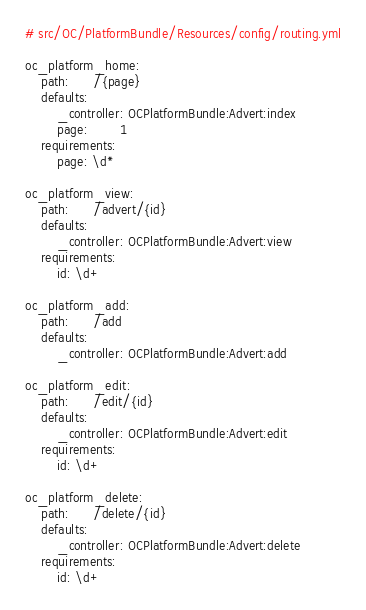Convert code to text. <code><loc_0><loc_0><loc_500><loc_500><_YAML_># src/OC/PlatformBundle/Resources/config/routing.yml

oc_platform_home:
    path:      /{page}
    defaults:
        _controller: OCPlatformBundle:Advert:index
        page:        1
    requirements:
        page: \d*
  
oc_platform_view:
    path:      /advert/{id}
    defaults:
        _controller: OCPlatformBundle:Advert:view
    requirements:
        id: \d+

oc_platform_add:
    path:      /add
    defaults:
        _controller: OCPlatformBundle:Advert:add

oc_platform_edit:
    path:      /edit/{id}
    defaults:
        _controller: OCPlatformBundle:Advert:edit
    requirements:
        id: \d+

oc_platform_delete:
    path:      /delete/{id}
    defaults:
        _controller: OCPlatformBundle:Advert:delete
    requirements:
        id: \d+
</code> 